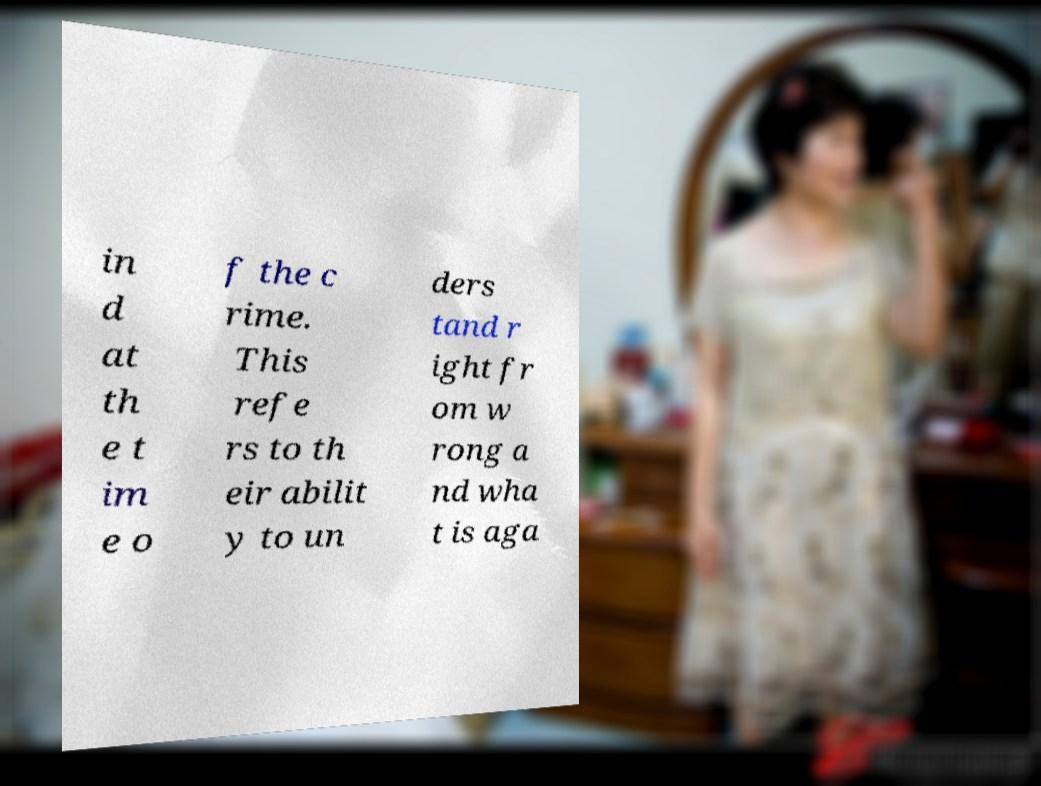Please identify and transcribe the text found in this image. in d at th e t im e o f the c rime. This refe rs to th eir abilit y to un ders tand r ight fr om w rong a nd wha t is aga 